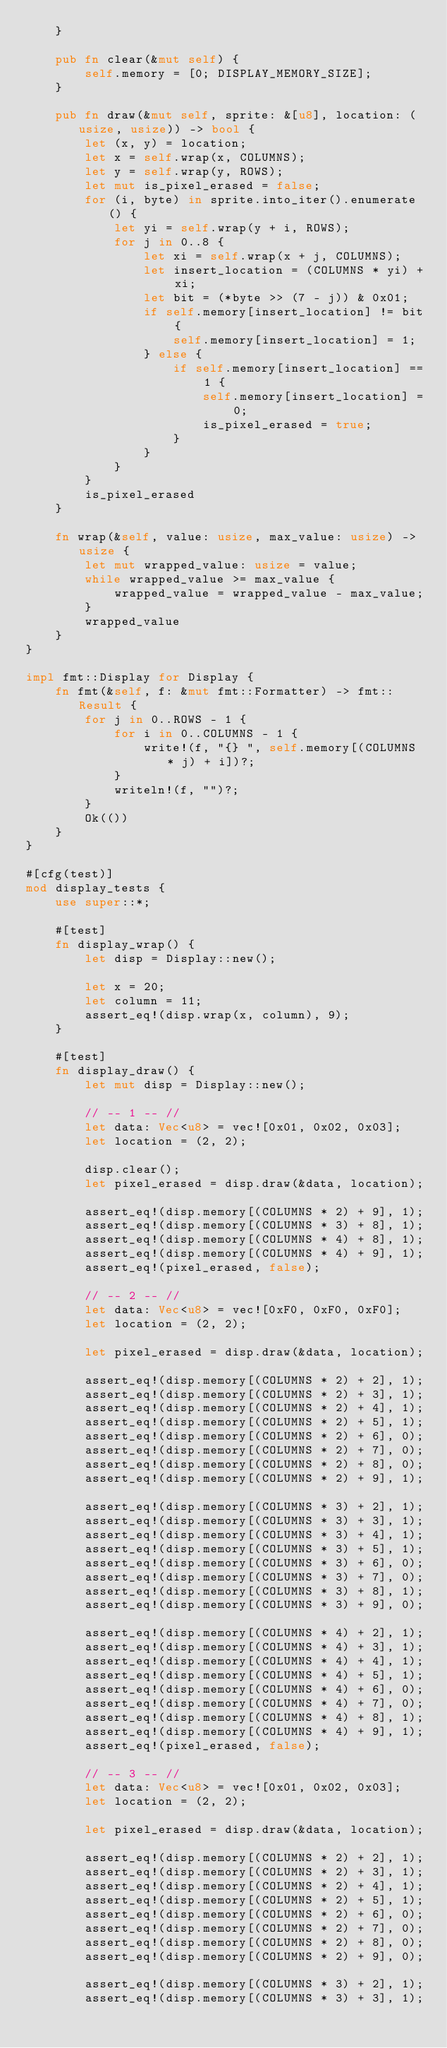<code> <loc_0><loc_0><loc_500><loc_500><_Rust_>    }

    pub fn clear(&mut self) {
        self.memory = [0; DISPLAY_MEMORY_SIZE];
    }

    pub fn draw(&mut self, sprite: &[u8], location: (usize, usize)) -> bool {
        let (x, y) = location;
        let x = self.wrap(x, COLUMNS);
        let y = self.wrap(y, ROWS);
        let mut is_pixel_erased = false;
        for (i, byte) in sprite.into_iter().enumerate() {
            let yi = self.wrap(y + i, ROWS);
            for j in 0..8 {
                let xi = self.wrap(x + j, COLUMNS);
                let insert_location = (COLUMNS * yi) + xi;
                let bit = (*byte >> (7 - j)) & 0x01;
                if self.memory[insert_location] != bit {
                    self.memory[insert_location] = 1;
                } else {
                    if self.memory[insert_location] == 1 {
                        self.memory[insert_location] = 0;
                        is_pixel_erased = true;
                    }
                }
            }
        }
        is_pixel_erased
    }

    fn wrap(&self, value: usize, max_value: usize) -> usize {
        let mut wrapped_value: usize = value;
        while wrapped_value >= max_value {
            wrapped_value = wrapped_value - max_value;
        }
        wrapped_value
    }
}

impl fmt::Display for Display {
    fn fmt(&self, f: &mut fmt::Formatter) -> fmt::Result {
        for j in 0..ROWS - 1 {
            for i in 0..COLUMNS - 1 {
                write!(f, "{} ", self.memory[(COLUMNS * j) + i])?;
            }
            writeln!(f, "")?;
        }
        Ok(())
    }
}

#[cfg(test)]
mod display_tests {
    use super::*;

    #[test]
    fn display_wrap() {
        let disp = Display::new();

        let x = 20;
        let column = 11;
        assert_eq!(disp.wrap(x, column), 9);
    }

    #[test]
    fn display_draw() {
        let mut disp = Display::new();

        // -- 1 -- //
        let data: Vec<u8> = vec![0x01, 0x02, 0x03];
        let location = (2, 2);

        disp.clear();
        let pixel_erased = disp.draw(&data, location);

        assert_eq!(disp.memory[(COLUMNS * 2) + 9], 1);
        assert_eq!(disp.memory[(COLUMNS * 3) + 8], 1);
        assert_eq!(disp.memory[(COLUMNS * 4) + 8], 1);
        assert_eq!(disp.memory[(COLUMNS * 4) + 9], 1);
        assert_eq!(pixel_erased, false);

        // -- 2 -- //
        let data: Vec<u8> = vec![0xF0, 0xF0, 0xF0];
        let location = (2, 2);

        let pixel_erased = disp.draw(&data, location);

        assert_eq!(disp.memory[(COLUMNS * 2) + 2], 1);
        assert_eq!(disp.memory[(COLUMNS * 2) + 3], 1);
        assert_eq!(disp.memory[(COLUMNS * 2) + 4], 1);
        assert_eq!(disp.memory[(COLUMNS * 2) + 5], 1);
        assert_eq!(disp.memory[(COLUMNS * 2) + 6], 0);
        assert_eq!(disp.memory[(COLUMNS * 2) + 7], 0);
        assert_eq!(disp.memory[(COLUMNS * 2) + 8], 0);
        assert_eq!(disp.memory[(COLUMNS * 2) + 9], 1);

        assert_eq!(disp.memory[(COLUMNS * 3) + 2], 1);
        assert_eq!(disp.memory[(COLUMNS * 3) + 3], 1);
        assert_eq!(disp.memory[(COLUMNS * 3) + 4], 1);
        assert_eq!(disp.memory[(COLUMNS * 3) + 5], 1);
        assert_eq!(disp.memory[(COLUMNS * 3) + 6], 0);
        assert_eq!(disp.memory[(COLUMNS * 3) + 7], 0);
        assert_eq!(disp.memory[(COLUMNS * 3) + 8], 1);
        assert_eq!(disp.memory[(COLUMNS * 3) + 9], 0);

        assert_eq!(disp.memory[(COLUMNS * 4) + 2], 1);
        assert_eq!(disp.memory[(COLUMNS * 4) + 3], 1);
        assert_eq!(disp.memory[(COLUMNS * 4) + 4], 1);
        assert_eq!(disp.memory[(COLUMNS * 4) + 5], 1);
        assert_eq!(disp.memory[(COLUMNS * 4) + 6], 0);
        assert_eq!(disp.memory[(COLUMNS * 4) + 7], 0);
        assert_eq!(disp.memory[(COLUMNS * 4) + 8], 1);
        assert_eq!(disp.memory[(COLUMNS * 4) + 9], 1);
        assert_eq!(pixel_erased, false);

        // -- 3 -- //
        let data: Vec<u8> = vec![0x01, 0x02, 0x03];
        let location = (2, 2);

        let pixel_erased = disp.draw(&data, location);

        assert_eq!(disp.memory[(COLUMNS * 2) + 2], 1);
        assert_eq!(disp.memory[(COLUMNS * 2) + 3], 1);
        assert_eq!(disp.memory[(COLUMNS * 2) + 4], 1);
        assert_eq!(disp.memory[(COLUMNS * 2) + 5], 1);
        assert_eq!(disp.memory[(COLUMNS * 2) + 6], 0);
        assert_eq!(disp.memory[(COLUMNS * 2) + 7], 0);
        assert_eq!(disp.memory[(COLUMNS * 2) + 8], 0);
        assert_eq!(disp.memory[(COLUMNS * 2) + 9], 0);

        assert_eq!(disp.memory[(COLUMNS * 3) + 2], 1);
        assert_eq!(disp.memory[(COLUMNS * 3) + 3], 1);</code> 